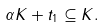<formula> <loc_0><loc_0><loc_500><loc_500>\alpha K + t _ { 1 } \subseteq K .</formula> 